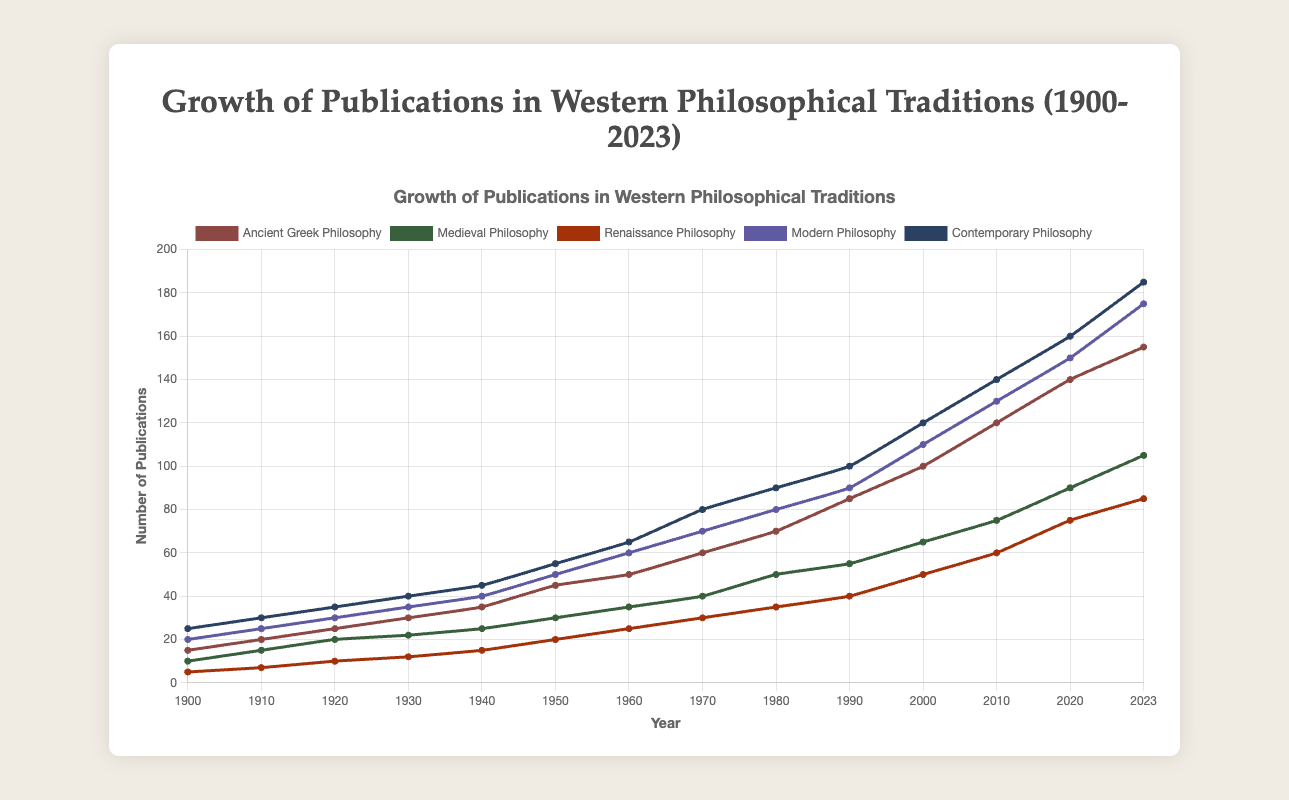How does the number of publications in Ancient Greek Philosophy compare to Medieval Philosophy in 2023? To compare the number of publications, look at the data points for Ancient Greek Philosophy and Medieval Philosophy in 2023. Ancient Greek Philosophy has 155 publications, and Medieval Philosophy has 105 publications.
Answer: Ancient Greek Philosophy has more publications Which philosophical tradition showed the highest growth in publications between 1900 and 2023? To find the highest growth, calculate the difference between the numbers in 2023 and 1900 for each tradition. Ancient Greek Philosophy: 155-15 = 140, Medieval Philosophy: 105-10 = 95, Renaissance Philosophy: 85-5 = 80, Modern Philosophy: 175-20 = 155, Contemporary Philosophy: 185-25 = 160. The highest growth is in Contemporary Philosophy.
Answer: Contemporary Philosophy By how much did the publications in Ancient Greek Philosophy increase from 2000 to 2023? Find the difference between the publication numbers in 2023 and 2000 for Ancient Greek Philosophy: 155 - 100 = 55.
Answer: 55 During which decade did Ancient Greek Philosophy see the highest increase in publications? Calculate the increase in publications for each decade by subtracting the beginning value of the decade from the ending value. The largest increase is between 2010 and 2020 (140 - 120 = 20).
Answer: 2010-2020 Which philosophical tradition had the smallest number of publications in 1920? The smallest number in 1920 can be observed by examining the data: Ancient Greek Philosophy: 25, Medieval Philosophy: 20, Renaissance Philosophy: 10, Modern Philosophy: 30, Contemporary Philosophy: 35. Renaissance Philosophy has the smallest number.
Answer: Renaissance Philosophy What was the average annual growth rate of publications in Contemporary Philosophy from 1900 to 2023? First find the total growth: 185 (2023) - 25 (1900) = 160. Divide this by the number of years: 160 / (2023 - 1900) = 1.31 publications per year.
Answer: 1.31 How many more publications were there in Modern Philosophy than in Renaissance Philosophy in 2020? Subtract the number of publications in Renaissance Philosophy from Modern Philosophy in 2020: 150 - 75 = 75.
Answer: 75 Is there any decade where the growth of publications in Renaissance Philosophy was zero? Examine the differences in the number of publications for Renaissance Philosophy across decades. The differences are always positive, so in each decade, there was some growth.
Answer: No What color represents Medieval Philosophy in the line plot? The visually distinguishing color for Medieval Philosophy can be observed directly from the plot. Medieval Philosophy is represented by green.
Answer: Green 